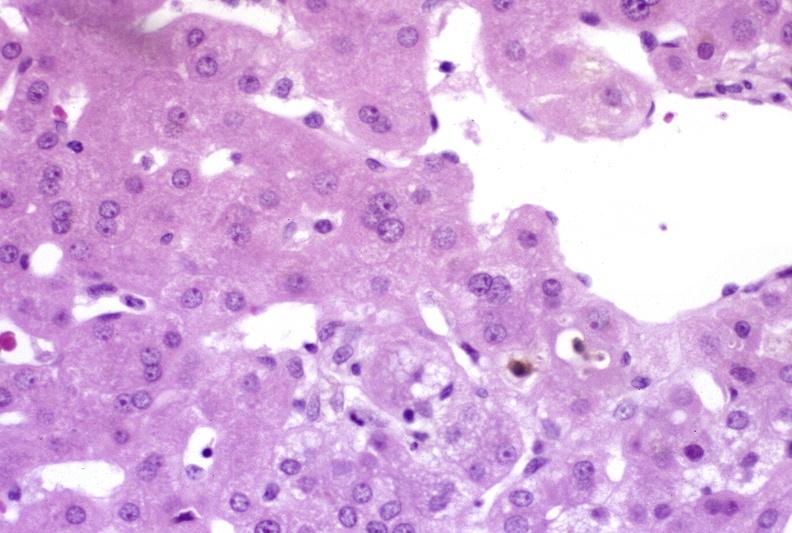what does this image show?
Answer the question using a single word or phrase. Ductopenia 